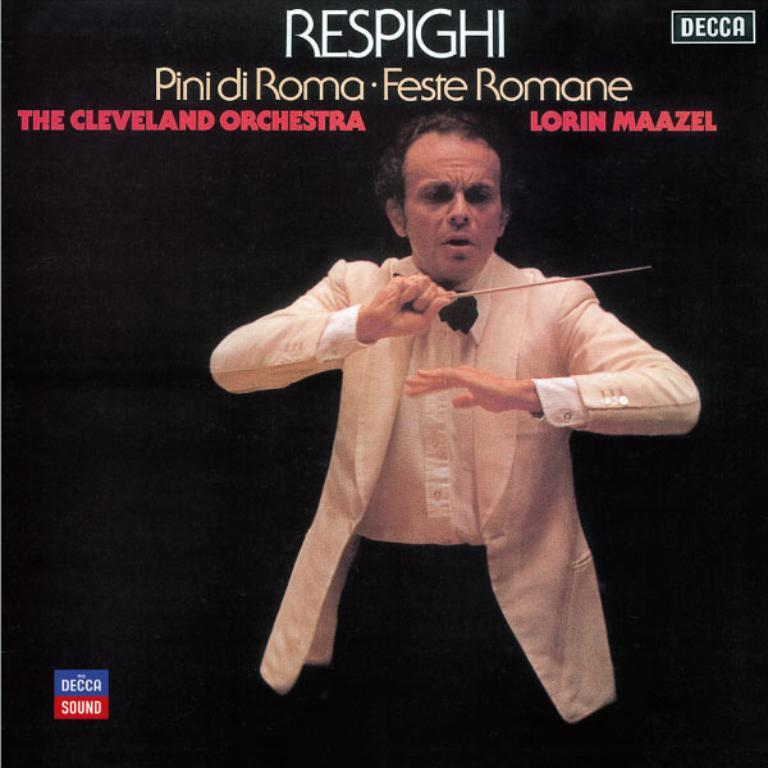What can be seen in the image? There is a person in the image. Can you describe the person's attire? The person is wearing a white suit. What is the person holding in his hand? The person is holding a stick in his hand. What is written above the person? Unfortunately, the facts provided do not specify what is written above the person. What type of egg is being used as a sofa in the image? There is no egg or sofa present in the image. 